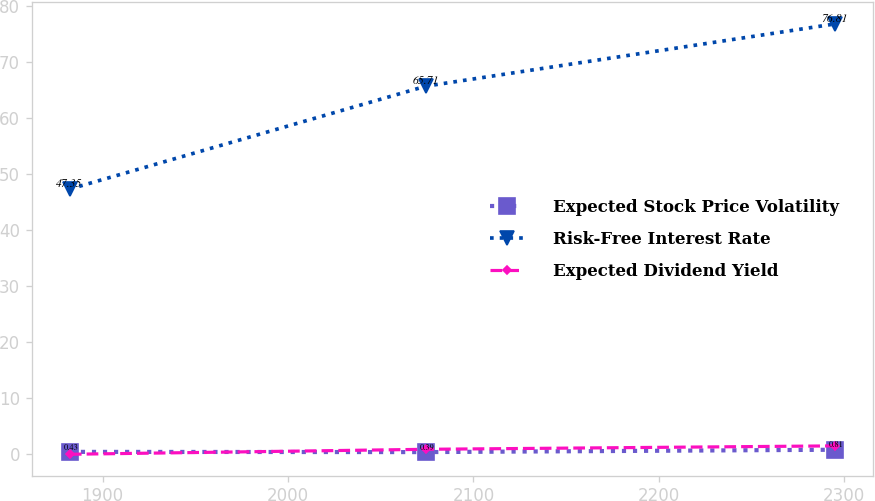Convert chart. <chart><loc_0><loc_0><loc_500><loc_500><line_chart><ecel><fcel>Expected Stock Price Volatility<fcel>Risk-Free Interest Rate<fcel>Expected Dividend Yield<nl><fcel>1882.33<fcel>0.43<fcel>47.35<fcel>0<nl><fcel>2074.33<fcel>0.39<fcel>65.71<fcel>0.89<nl><fcel>2294.79<fcel>0.81<fcel>76.81<fcel>1.5<nl></chart> 